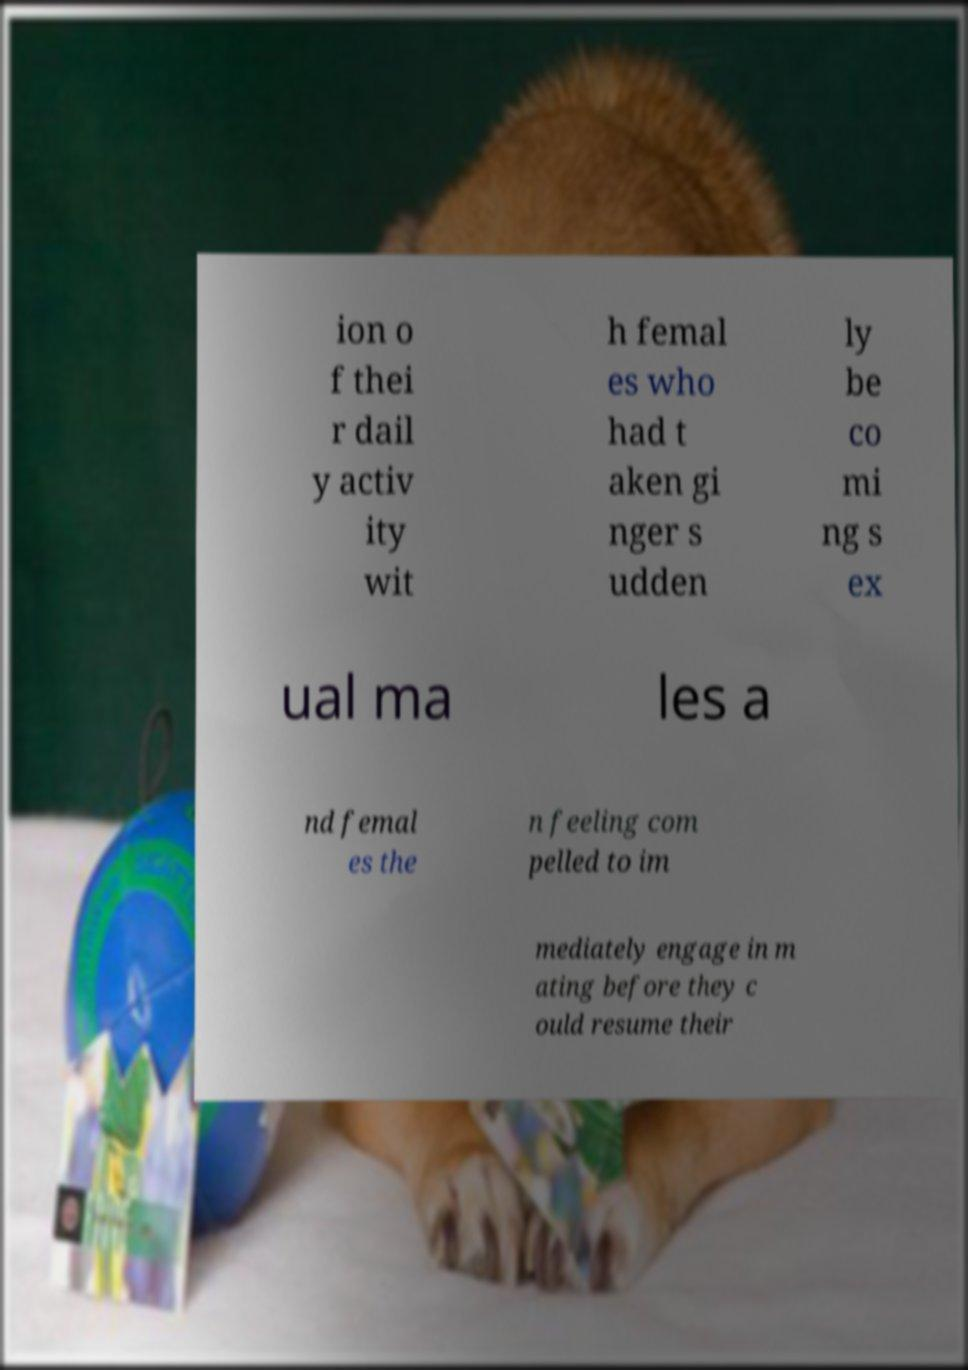Could you assist in decoding the text presented in this image and type it out clearly? ion o f thei r dail y activ ity wit h femal es who had t aken gi nger s udden ly be co mi ng s ex ual ma les a nd femal es the n feeling com pelled to im mediately engage in m ating before they c ould resume their 